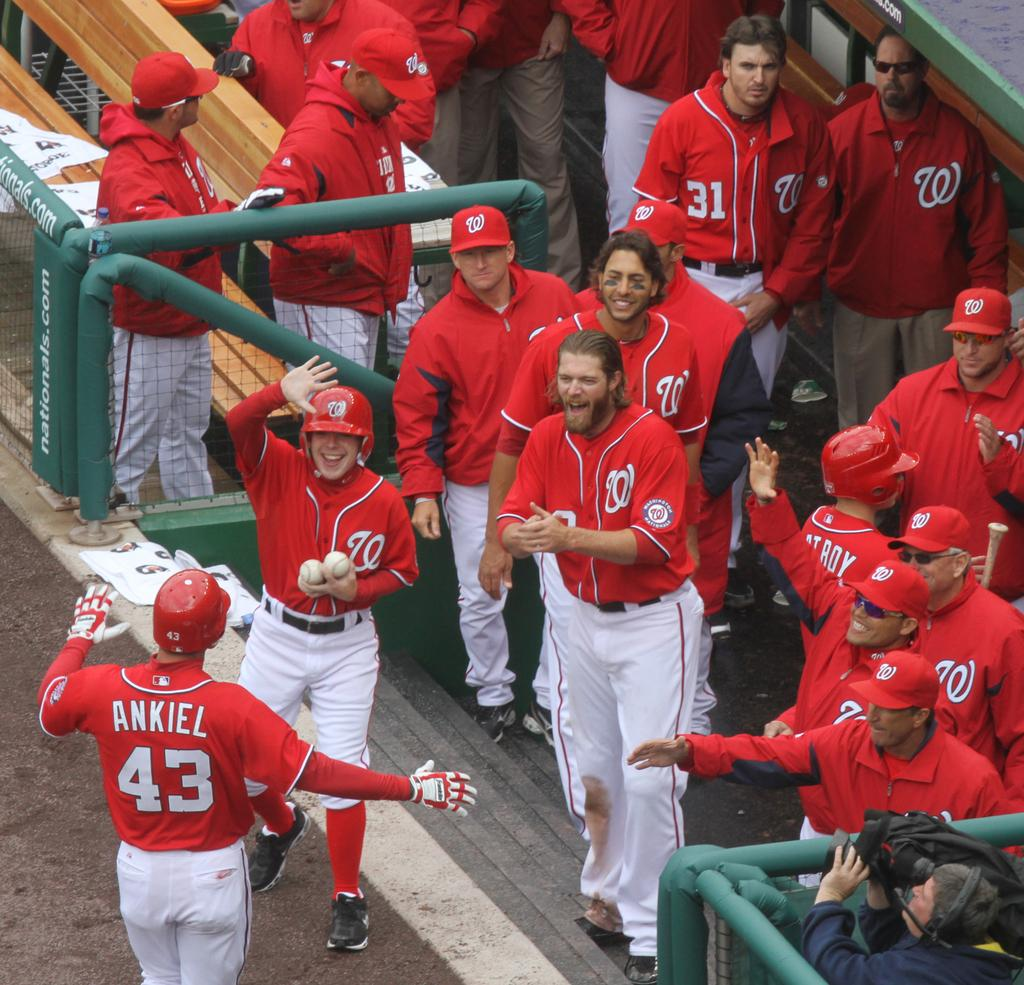<image>
Create a compact narrative representing the image presented. Baseball player wearing number 43 headed back to greet his teammates. 